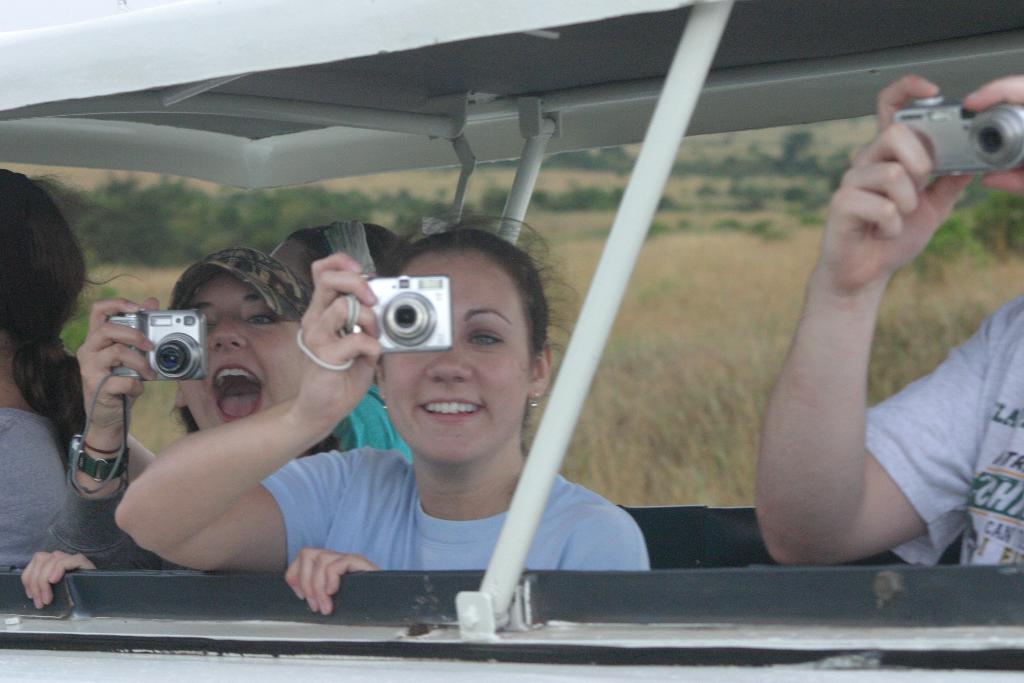Please provide a concise description of this image. In this image there is a vehicle. Few persons are in vehicle. Few persons are holding cameras in their hand. Behind them there is grassland having few trees. 